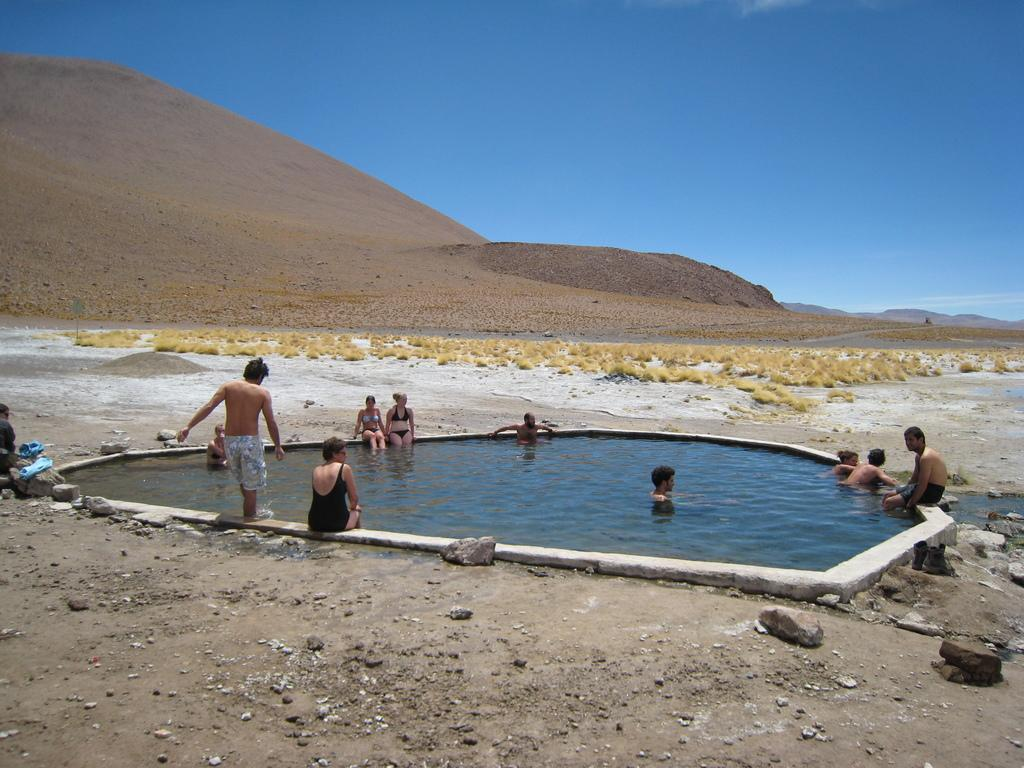What type of terrain is visible on the ground in the image? The ground in the image has rocks and grass. What body of water can be seen in the image? There is a swimming pool in the image. Can you describe the people in the image? There are people in the image, but their specific actions or appearances are not mentioned in the facts. What type of natural formation is visible in the distance? Mountains are visible in the image. What else is visible in the image besides the ground and people? The sky is visible in the image. What type of gun is being used by the queen in the image? There is no queen or gun present in the image. 